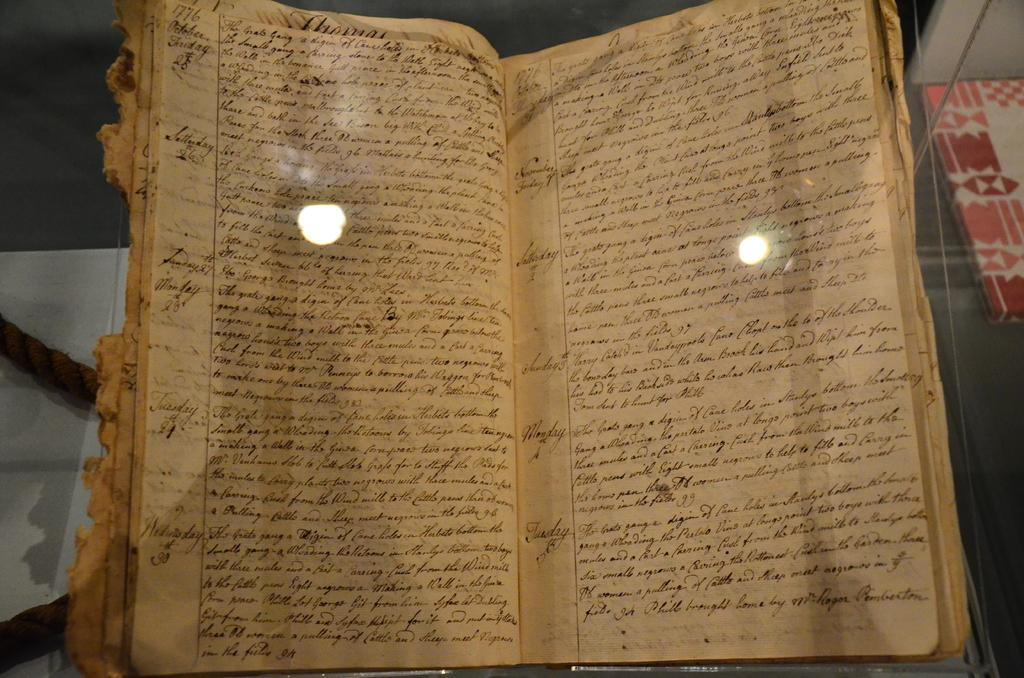Provide a one-sentence caption for the provided image. A worn out log book showing the days Thursday, Friday, Saturday and so on. 